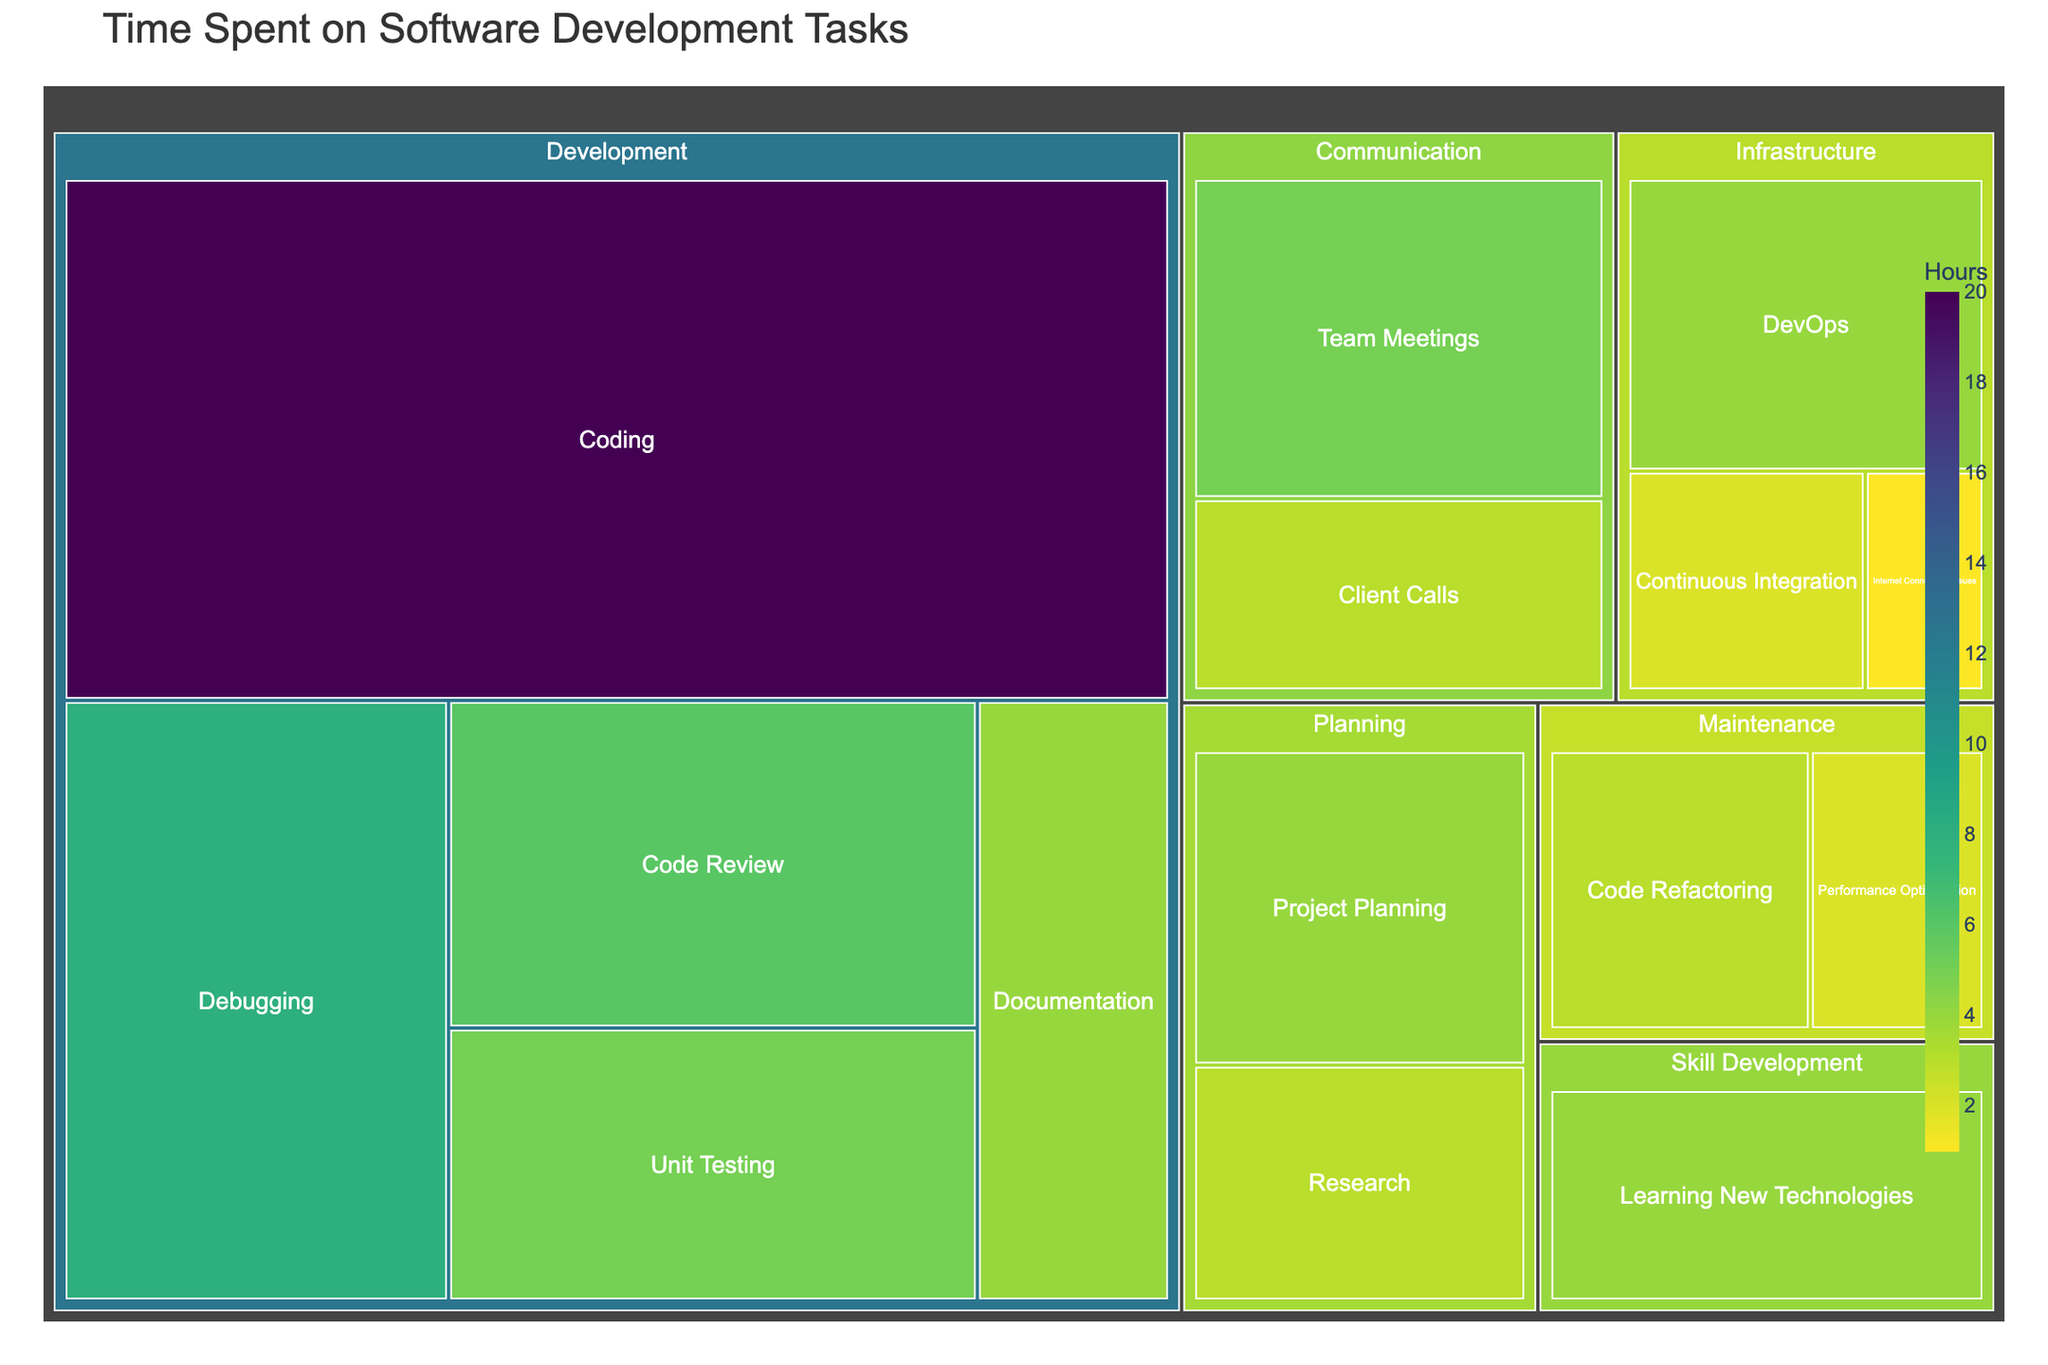What's the title of the figure? The title is placed at the top of the figure, typically in a larger and more distinct font. It provides an overview of what the chart represents.
Answer: Time Spent on Software Development Tasks How many hours are spent on Development tasks total? To find this, sum the hours of all tasks under the 'Development' category: Coding (20) + Code Review (6) + Debugging (8) + Unit Testing (5) + Documentation (4).
Answer: 43 hours Which task uses the least amount of hours? Look for the smallest segment in the treemap. According to the provided data, 'Internet Connectivity Issues' has the smallest value with 1 hour.
Answer: Internet Connectivity Issues What is the color used to represent tasks with the highest hours? Tasks with higher hours will be represented by the color at the end of the color scale specified, which is a reversed Viridis scheme. This is typically noted in the legend. The darkest color in the reversed Viridis scale will represent the highest value.
Answer: Darkest color in the reversed Viridis scale How many hours are spent on Communication tasks total? Sum the hours across all tasks under the 'Communication' category: Team Meetings (5) + Client Calls (3).
Answer: 8 hours Which category has the highest total hours? Sum the hours for each category and compare: Development (43), Communication (8), Planning (7), Infrastructure (7), Skill Development (4), Maintenance (5). The highest sum is for the 'Development' category.
Answer: Development How many hours are spent on Maintenance tasks total? Sum the hours of all tasks under the 'Maintenance' category: Code Refactoring (3) + Performance Optimization (2).
Answer: 5 hours Is more time spent on Debugging or Unit Testing? Compare the hours spent on Debugging (8) and Unit Testing (5). Debugging has more hours.
Answer: Debugging What task in the Planning category has more hours dedicated to it? Compare the hours spent on tasks under 'Planning': Project Planning (4) and Research (3). Project Planning has more hours.
Answer: Project Planning Which Infrastructure task has the more hours, DevOps or Continuous Integration? Compare the hours spent on DevOps (4) and Continuous Integration (2). DevOps has more hours.
Answer: DevOps 